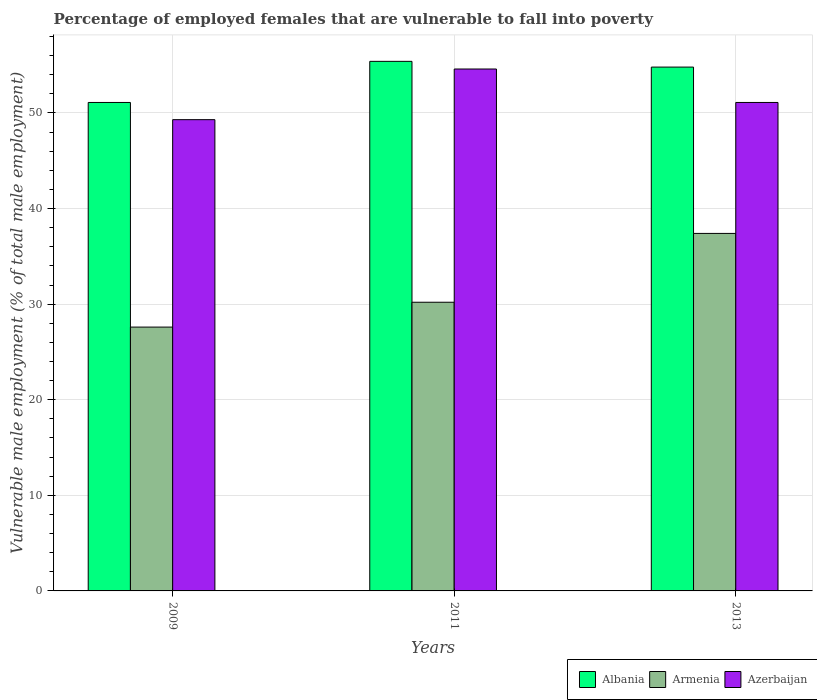How many different coloured bars are there?
Your answer should be compact. 3. How many groups of bars are there?
Provide a short and direct response. 3. Are the number of bars per tick equal to the number of legend labels?
Offer a terse response. Yes. Are the number of bars on each tick of the X-axis equal?
Your response must be concise. Yes. How many bars are there on the 2nd tick from the right?
Offer a very short reply. 3. What is the label of the 3rd group of bars from the left?
Provide a short and direct response. 2013. What is the percentage of employed females who are vulnerable to fall into poverty in Azerbaijan in 2009?
Your answer should be very brief. 49.3. Across all years, what is the maximum percentage of employed females who are vulnerable to fall into poverty in Albania?
Your answer should be very brief. 55.4. Across all years, what is the minimum percentage of employed females who are vulnerable to fall into poverty in Armenia?
Ensure brevity in your answer.  27.6. In which year was the percentage of employed females who are vulnerable to fall into poverty in Albania maximum?
Provide a succinct answer. 2011. In which year was the percentage of employed females who are vulnerable to fall into poverty in Armenia minimum?
Ensure brevity in your answer.  2009. What is the total percentage of employed females who are vulnerable to fall into poverty in Azerbaijan in the graph?
Give a very brief answer. 155. What is the difference between the percentage of employed females who are vulnerable to fall into poverty in Armenia in 2009 and that in 2013?
Keep it short and to the point. -9.8. What is the difference between the percentage of employed females who are vulnerable to fall into poverty in Armenia in 2011 and the percentage of employed females who are vulnerable to fall into poverty in Azerbaijan in 2009?
Your answer should be compact. -19.1. What is the average percentage of employed females who are vulnerable to fall into poverty in Albania per year?
Provide a succinct answer. 53.77. In the year 2013, what is the difference between the percentage of employed females who are vulnerable to fall into poverty in Azerbaijan and percentage of employed females who are vulnerable to fall into poverty in Armenia?
Offer a terse response. 13.7. What is the ratio of the percentage of employed females who are vulnerable to fall into poverty in Azerbaijan in 2009 to that in 2011?
Your answer should be very brief. 0.9. Is the difference between the percentage of employed females who are vulnerable to fall into poverty in Azerbaijan in 2009 and 2013 greater than the difference between the percentage of employed females who are vulnerable to fall into poverty in Armenia in 2009 and 2013?
Your response must be concise. Yes. What is the difference between the highest and the second highest percentage of employed females who are vulnerable to fall into poverty in Azerbaijan?
Your answer should be very brief. 3.5. What is the difference between the highest and the lowest percentage of employed females who are vulnerable to fall into poverty in Albania?
Give a very brief answer. 4.3. Is the sum of the percentage of employed females who are vulnerable to fall into poverty in Azerbaijan in 2009 and 2013 greater than the maximum percentage of employed females who are vulnerable to fall into poverty in Armenia across all years?
Ensure brevity in your answer.  Yes. What does the 1st bar from the left in 2009 represents?
Ensure brevity in your answer.  Albania. What does the 2nd bar from the right in 2009 represents?
Your response must be concise. Armenia. How many bars are there?
Your response must be concise. 9. How many years are there in the graph?
Provide a succinct answer. 3. What is the difference between two consecutive major ticks on the Y-axis?
Your answer should be very brief. 10. Are the values on the major ticks of Y-axis written in scientific E-notation?
Your answer should be very brief. No. Does the graph contain any zero values?
Your response must be concise. No. Where does the legend appear in the graph?
Your response must be concise. Bottom right. What is the title of the graph?
Offer a terse response. Percentage of employed females that are vulnerable to fall into poverty. What is the label or title of the Y-axis?
Your answer should be very brief. Vulnerable male employment (% of total male employment). What is the Vulnerable male employment (% of total male employment) of Albania in 2009?
Your response must be concise. 51.1. What is the Vulnerable male employment (% of total male employment) in Armenia in 2009?
Give a very brief answer. 27.6. What is the Vulnerable male employment (% of total male employment) in Azerbaijan in 2009?
Your response must be concise. 49.3. What is the Vulnerable male employment (% of total male employment) in Albania in 2011?
Make the answer very short. 55.4. What is the Vulnerable male employment (% of total male employment) in Armenia in 2011?
Provide a succinct answer. 30.2. What is the Vulnerable male employment (% of total male employment) in Azerbaijan in 2011?
Make the answer very short. 54.6. What is the Vulnerable male employment (% of total male employment) of Albania in 2013?
Give a very brief answer. 54.8. What is the Vulnerable male employment (% of total male employment) in Armenia in 2013?
Offer a terse response. 37.4. What is the Vulnerable male employment (% of total male employment) of Azerbaijan in 2013?
Offer a terse response. 51.1. Across all years, what is the maximum Vulnerable male employment (% of total male employment) in Albania?
Make the answer very short. 55.4. Across all years, what is the maximum Vulnerable male employment (% of total male employment) in Armenia?
Provide a short and direct response. 37.4. Across all years, what is the maximum Vulnerable male employment (% of total male employment) of Azerbaijan?
Your response must be concise. 54.6. Across all years, what is the minimum Vulnerable male employment (% of total male employment) of Albania?
Keep it short and to the point. 51.1. Across all years, what is the minimum Vulnerable male employment (% of total male employment) of Armenia?
Offer a very short reply. 27.6. Across all years, what is the minimum Vulnerable male employment (% of total male employment) in Azerbaijan?
Your answer should be compact. 49.3. What is the total Vulnerable male employment (% of total male employment) of Albania in the graph?
Provide a short and direct response. 161.3. What is the total Vulnerable male employment (% of total male employment) in Armenia in the graph?
Your response must be concise. 95.2. What is the total Vulnerable male employment (% of total male employment) of Azerbaijan in the graph?
Ensure brevity in your answer.  155. What is the difference between the Vulnerable male employment (% of total male employment) in Albania in 2009 and that in 2011?
Your answer should be compact. -4.3. What is the difference between the Vulnerable male employment (% of total male employment) of Azerbaijan in 2009 and that in 2013?
Your answer should be very brief. -1.8. What is the difference between the Vulnerable male employment (% of total male employment) of Albania in 2009 and the Vulnerable male employment (% of total male employment) of Armenia in 2011?
Your answer should be very brief. 20.9. What is the difference between the Vulnerable male employment (% of total male employment) of Albania in 2009 and the Vulnerable male employment (% of total male employment) of Azerbaijan in 2011?
Provide a succinct answer. -3.5. What is the difference between the Vulnerable male employment (% of total male employment) in Albania in 2009 and the Vulnerable male employment (% of total male employment) in Azerbaijan in 2013?
Ensure brevity in your answer.  0. What is the difference between the Vulnerable male employment (% of total male employment) in Armenia in 2009 and the Vulnerable male employment (% of total male employment) in Azerbaijan in 2013?
Offer a terse response. -23.5. What is the difference between the Vulnerable male employment (% of total male employment) in Armenia in 2011 and the Vulnerable male employment (% of total male employment) in Azerbaijan in 2013?
Ensure brevity in your answer.  -20.9. What is the average Vulnerable male employment (% of total male employment) of Albania per year?
Provide a succinct answer. 53.77. What is the average Vulnerable male employment (% of total male employment) of Armenia per year?
Your answer should be compact. 31.73. What is the average Vulnerable male employment (% of total male employment) in Azerbaijan per year?
Provide a short and direct response. 51.67. In the year 2009, what is the difference between the Vulnerable male employment (% of total male employment) in Armenia and Vulnerable male employment (% of total male employment) in Azerbaijan?
Offer a very short reply. -21.7. In the year 2011, what is the difference between the Vulnerable male employment (% of total male employment) of Albania and Vulnerable male employment (% of total male employment) of Armenia?
Make the answer very short. 25.2. In the year 2011, what is the difference between the Vulnerable male employment (% of total male employment) in Armenia and Vulnerable male employment (% of total male employment) in Azerbaijan?
Your response must be concise. -24.4. In the year 2013, what is the difference between the Vulnerable male employment (% of total male employment) in Armenia and Vulnerable male employment (% of total male employment) in Azerbaijan?
Offer a very short reply. -13.7. What is the ratio of the Vulnerable male employment (% of total male employment) in Albania in 2009 to that in 2011?
Offer a terse response. 0.92. What is the ratio of the Vulnerable male employment (% of total male employment) of Armenia in 2009 to that in 2011?
Provide a succinct answer. 0.91. What is the ratio of the Vulnerable male employment (% of total male employment) in Azerbaijan in 2009 to that in 2011?
Provide a short and direct response. 0.9. What is the ratio of the Vulnerable male employment (% of total male employment) in Albania in 2009 to that in 2013?
Your response must be concise. 0.93. What is the ratio of the Vulnerable male employment (% of total male employment) in Armenia in 2009 to that in 2013?
Your answer should be compact. 0.74. What is the ratio of the Vulnerable male employment (% of total male employment) of Azerbaijan in 2009 to that in 2013?
Your answer should be very brief. 0.96. What is the ratio of the Vulnerable male employment (% of total male employment) in Albania in 2011 to that in 2013?
Your answer should be compact. 1.01. What is the ratio of the Vulnerable male employment (% of total male employment) in Armenia in 2011 to that in 2013?
Make the answer very short. 0.81. What is the ratio of the Vulnerable male employment (% of total male employment) of Azerbaijan in 2011 to that in 2013?
Provide a succinct answer. 1.07. What is the difference between the highest and the lowest Vulnerable male employment (% of total male employment) of Albania?
Make the answer very short. 4.3. What is the difference between the highest and the lowest Vulnerable male employment (% of total male employment) in Armenia?
Offer a very short reply. 9.8. What is the difference between the highest and the lowest Vulnerable male employment (% of total male employment) in Azerbaijan?
Make the answer very short. 5.3. 